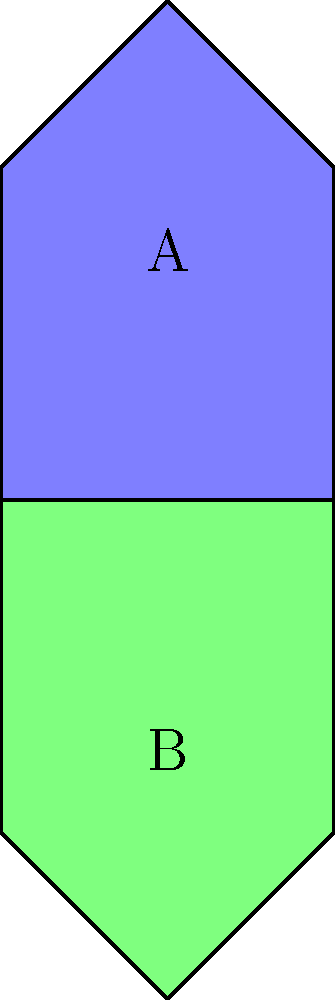Which of the following statements is true about shapes A and B?

a) Shape B is a 90-degree rotation of shape A
b) Shape B is a horizontal reflection of shape A
c) Shape B is a vertical reflection of shape A
d) Shape B is an exact copy of shape A To solve this problem, let's analyze the shapes step-by-step:

1. First, observe the overall orientation of both shapes. Shape A points upward, while Shape B points downward.

2. Compare the relative positions of the shapes' features:
   - The flat side of Shape A is at the bottom, while for Shape B, it's at the top.
   - The pointed part of Shape A is at the top, while for Shape B, it's at the bottom.

3. Consider each option:
   a) 90-degree rotation: If B were a rotation of A, the flat side would be on the left or right, not the top.
   b) Horizontal reflection: This would flip the shape left-to-right, which is not what we see.
   c) Vertical reflection: This would flip the shape top-to-bottom, which matches what we observe.
   d) Exact copy: The shapes are clearly different in orientation, so this is incorrect.

4. The vertical reflection (option c) correctly describes the relationship between Shapes A and B. Imagine a horizontal line between the shapes acting as a mirror - Shape B is the reflection of Shape A in this mirror.

This type of spatial reasoning is often used in manufacturing and design, where understanding how shapes relate to each other in different orientations is crucial.
Answer: b) Shape B is a horizontal reflection of shape A 